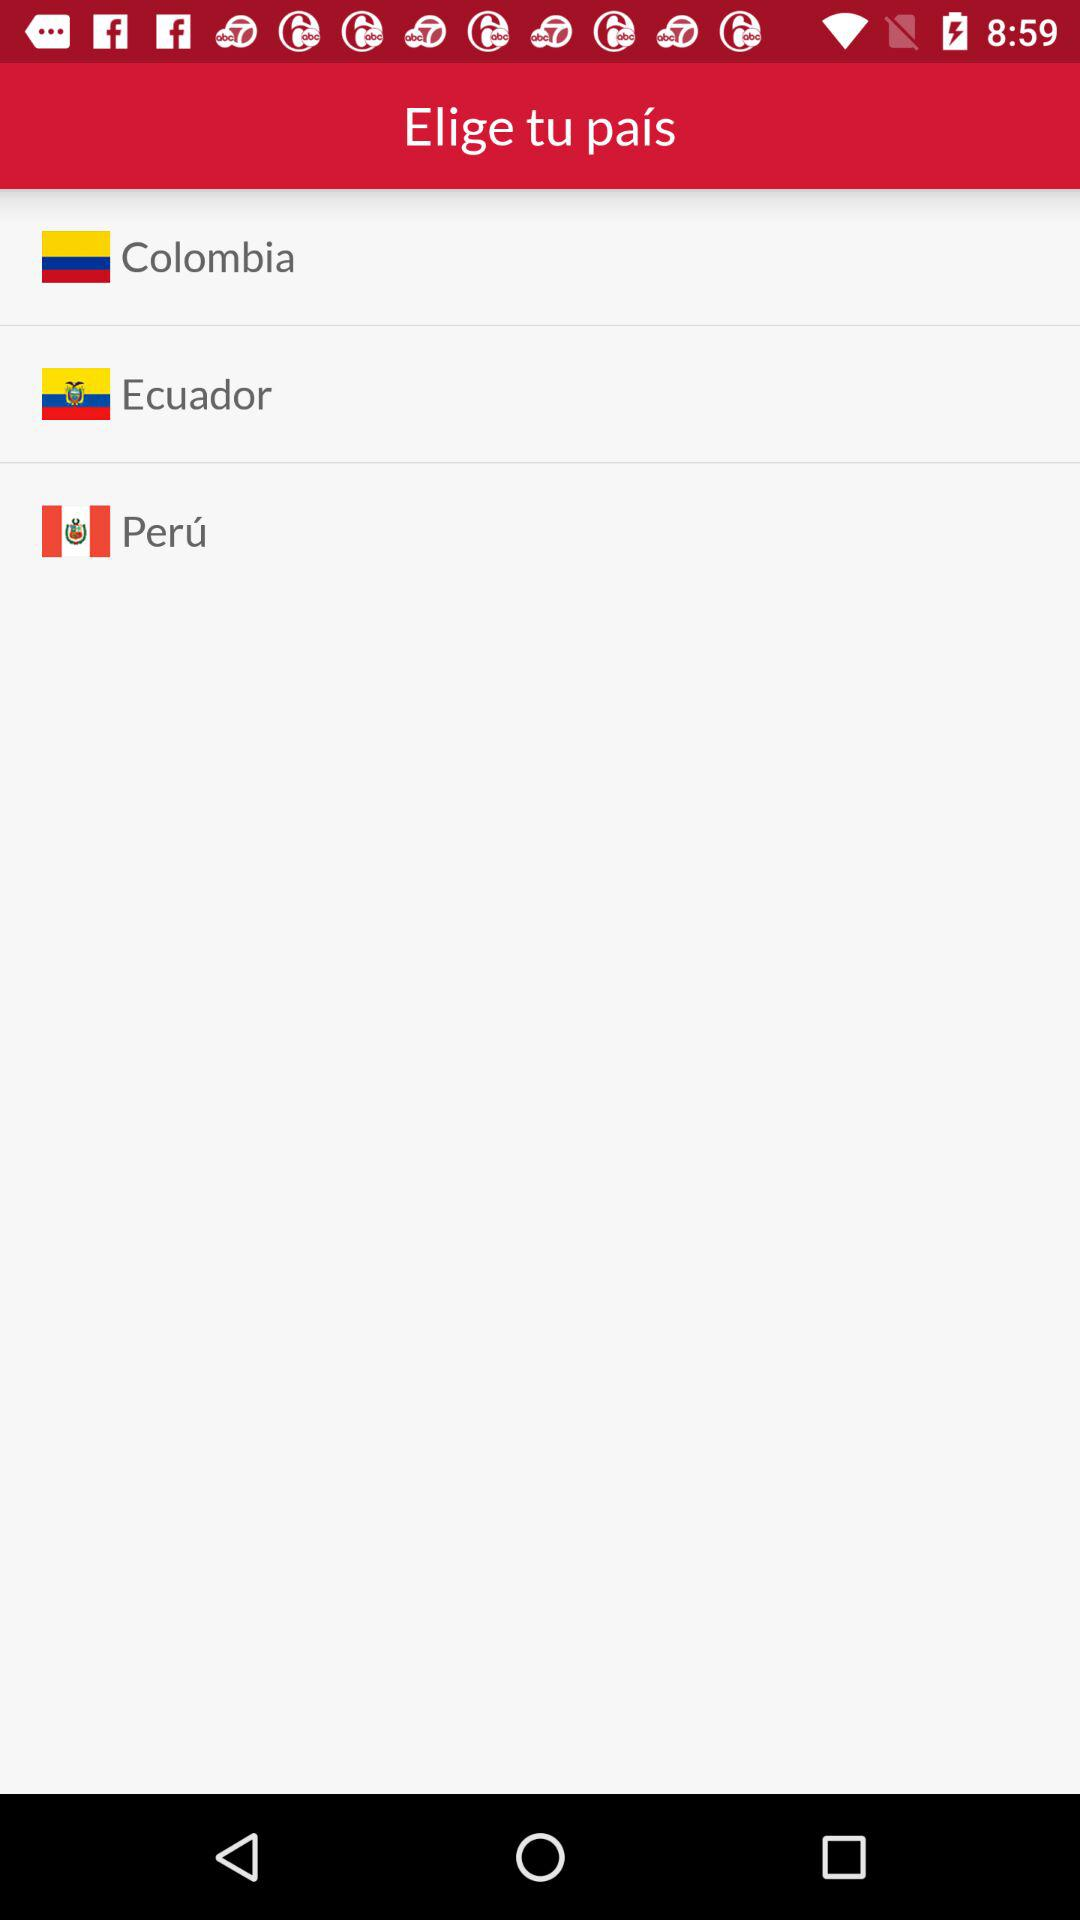How many countries are available to choose from?
Answer the question using a single word or phrase. 3 